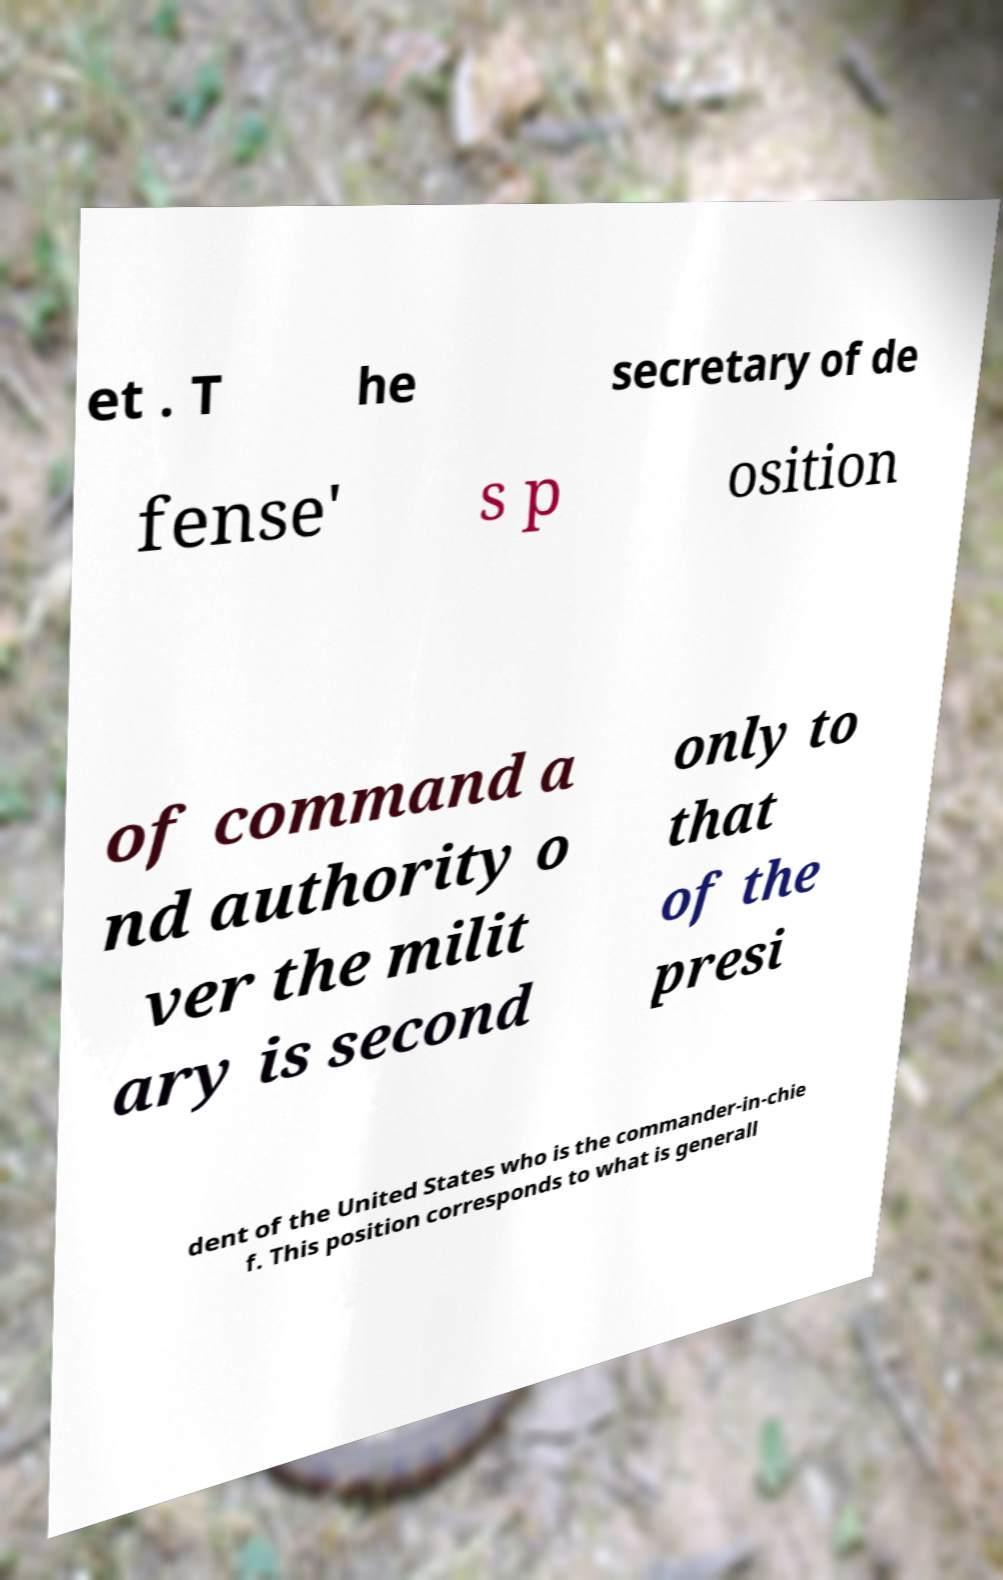Can you read and provide the text displayed in the image?This photo seems to have some interesting text. Can you extract and type it out for me? et . T he secretary of de fense' s p osition of command a nd authority o ver the milit ary is second only to that of the presi dent of the United States who is the commander-in-chie f. This position corresponds to what is generall 